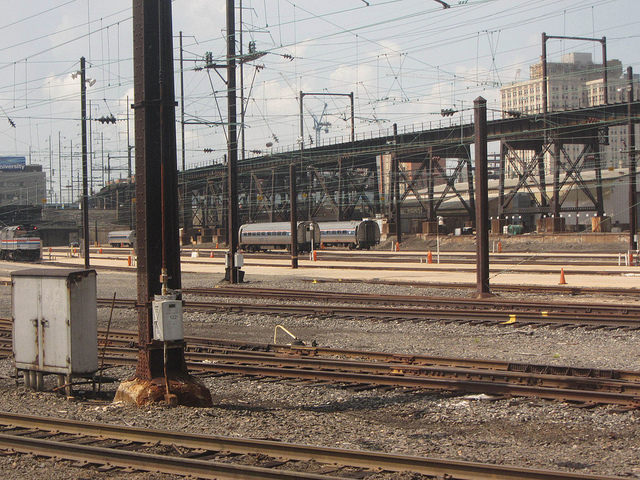<image>Where is the train? It's uncertain where the train is. However, it might be on the tracks or near a bridge. Where is the train? I don't know where the train is. It can be seen on the tracks, by the bridge, or in the city. 